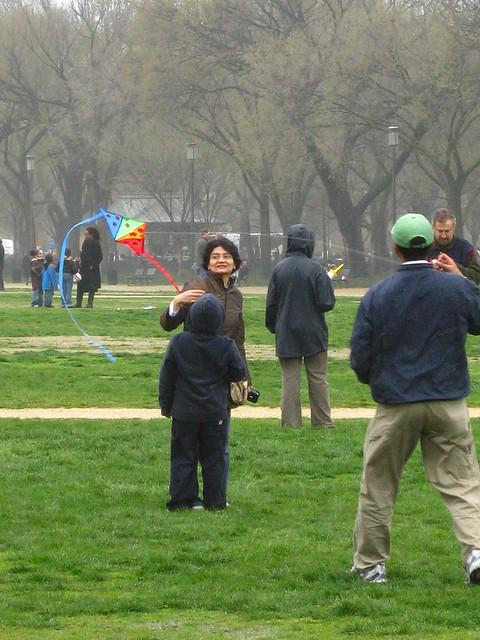Who is steering the flying object? Please explain your reasoning. man. You can tell by the fact that he is holding the kite string as to who is flying it. 